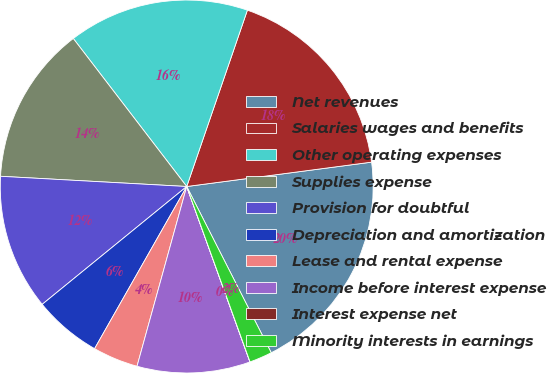Convert chart. <chart><loc_0><loc_0><loc_500><loc_500><pie_chart><fcel>Net revenues<fcel>Salaries wages and benefits<fcel>Other operating expenses<fcel>Supplies expense<fcel>Provision for doubtful<fcel>Depreciation and amortization<fcel>Lease and rental expense<fcel>Income before interest expense<fcel>Interest expense net<fcel>Minority interests in earnings<nl><fcel>19.6%<fcel>17.64%<fcel>15.68%<fcel>13.72%<fcel>11.76%<fcel>5.89%<fcel>3.93%<fcel>9.8%<fcel>0.01%<fcel>1.97%<nl></chart> 